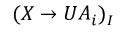<formula> <loc_0><loc_0><loc_500><loc_500>( X \to U A _ { i } ) _ { I }</formula> 